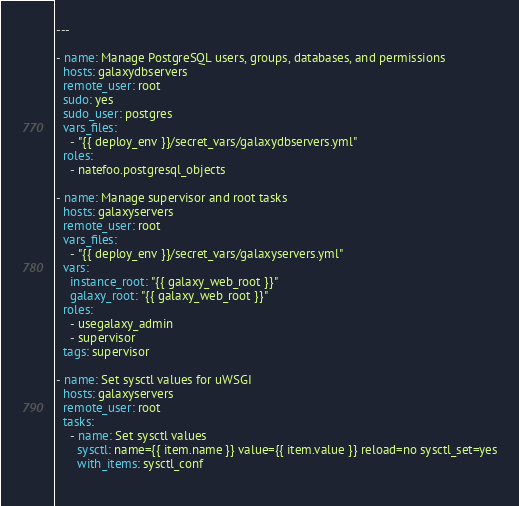Convert code to text. <code><loc_0><loc_0><loc_500><loc_500><_YAML_>---

- name: Manage PostgreSQL users, groups, databases, and permissions
  hosts: galaxydbservers
  remote_user: root
  sudo: yes
  sudo_user: postgres
  vars_files:
    - "{{ deploy_env }}/secret_vars/galaxydbservers.yml"
  roles:
    - natefoo.postgresql_objects

- name: Manage supervisor and root tasks
  hosts: galaxyservers
  remote_user: root
  vars_files:
    - "{{ deploy_env }}/secret_vars/galaxyservers.yml"
  vars:
    instance_root: "{{ galaxy_web_root }}"
    galaxy_root: "{{ galaxy_web_root }}"
  roles:
    - usegalaxy_admin
    - supervisor
  tags: supervisor

- name: Set sysctl values for uWSGI
  hosts: galaxyservers
  remote_user: root
  tasks:
    - name: Set sysctl values
      sysctl: name={{ item.name }} value={{ item.value }} reload=no sysctl_set=yes
      with_items: sysctl_conf
      
</code> 